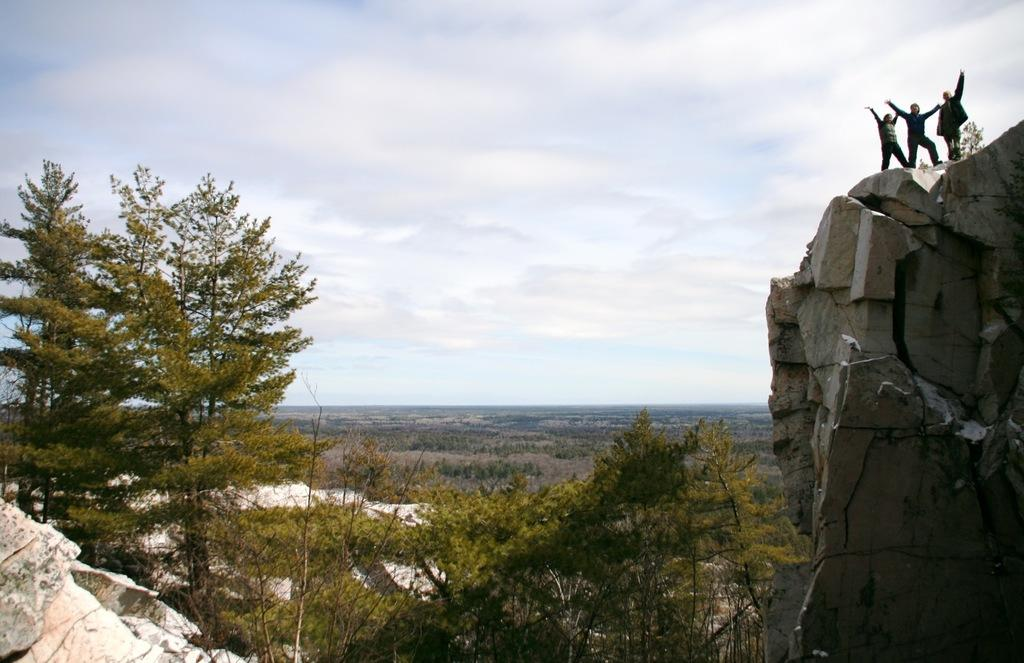How many people are in the image? There are three people in the image. What are the people doing in the image? The people are standing on a rock wall. What type of natural environment is depicted in the image? There are many trees and rocks in the image, suggesting a forest or mountainous area. What can be seen in the background of the image? The sky is visible in the background of the image. Where is the desk located in the image? There is no desk present in the image. What type of birth is being celebrated in the image? There is no indication of a birth or celebration in the image. 